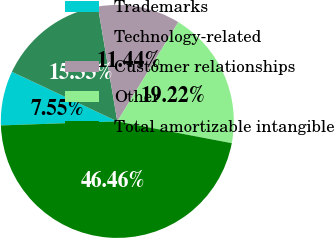Convert chart to OTSL. <chart><loc_0><loc_0><loc_500><loc_500><pie_chart><fcel>Trademarks<fcel>Technology-related<fcel>Customer relationships<fcel>Other<fcel>Total amortizable intangible<nl><fcel>7.55%<fcel>15.33%<fcel>11.44%<fcel>19.22%<fcel>46.46%<nl></chart> 